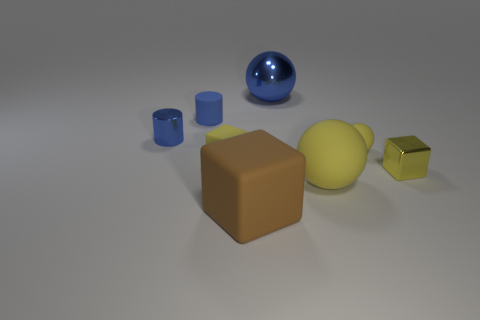Add 1 blue metal things. How many objects exist? 9 Subtract all large matte cubes. How many cubes are left? 2 Subtract all cylinders. How many objects are left? 6 Subtract all brown blocks. How many blocks are left? 2 Subtract 0 brown balls. How many objects are left? 8 Subtract 1 blocks. How many blocks are left? 2 Subtract all purple blocks. Subtract all purple balls. How many blocks are left? 3 Subtract all red blocks. How many brown cylinders are left? 0 Subtract all yellow rubber balls. Subtract all blue matte objects. How many objects are left? 5 Add 2 tiny blue objects. How many tiny blue objects are left? 4 